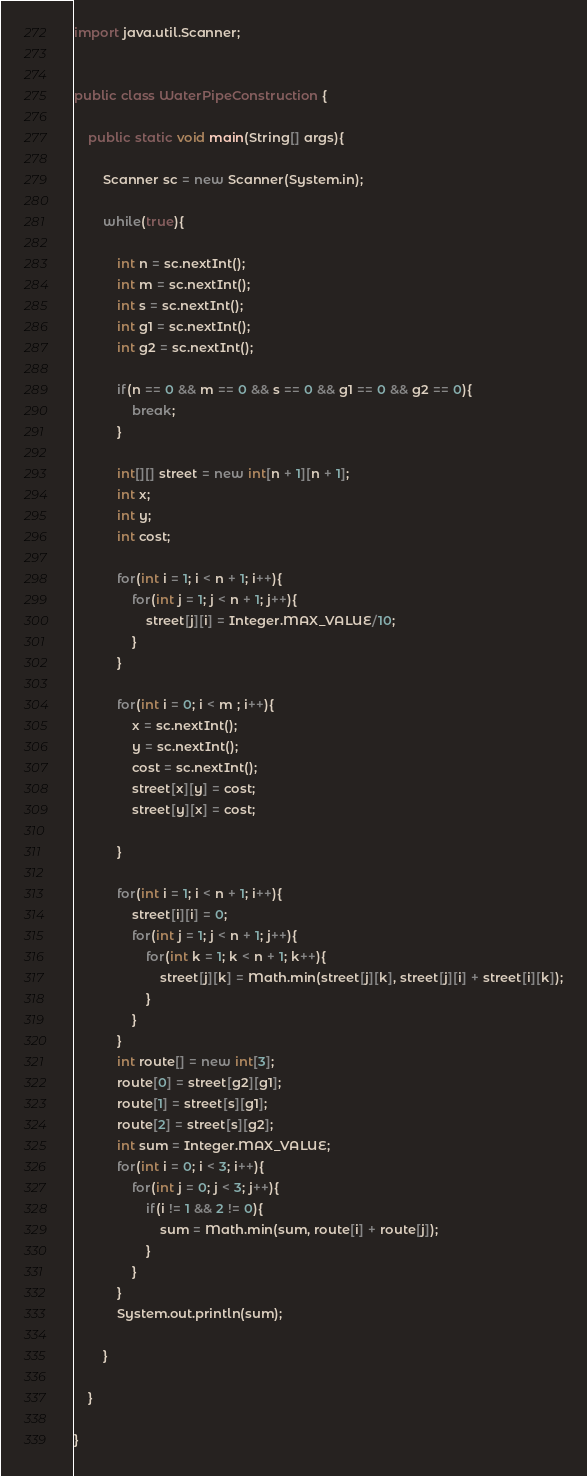Convert code to text. <code><loc_0><loc_0><loc_500><loc_500><_Java_>import java.util.Scanner;


public class WaterPipeConstruction {
	
	public static void main(String[] args){
		
		Scanner sc = new Scanner(System.in);
		
		while(true){
			
			int n = sc.nextInt();
			int m = sc.nextInt();
			int s = sc.nextInt();
			int g1 = sc.nextInt();
			int g2 = sc.nextInt();
			
			if(n == 0 && m == 0 && s == 0 && g1 == 0 && g2 == 0){
				break;
			}
			
			int[][] street = new int[n + 1][n + 1];
			int x;
			int y;
			int cost;
			
			for(int i = 1; i < n + 1; i++){
				for(int j = 1; j < n + 1; j++){
					street[j][i] = Integer.MAX_VALUE/10;
				}
			}
			
			for(int i = 0; i < m ; i++){
				x = sc.nextInt();
				y = sc.nextInt();
				cost = sc.nextInt();
				street[x][y] = cost;
				street[y][x] = cost;
				
			}
			
			for(int i = 1; i < n + 1; i++){
				street[i][i] = 0;
				for(int j = 1; j < n + 1; j++){
					for(int k = 1; k < n + 1; k++){
						street[j][k] = Math.min(street[j][k], street[j][i] + street[i][k]);
					}
				}
			}
			int route[] = new int[3];
			route[0] = street[g2][g1];
			route[1] = street[s][g1];
			route[2] = street[s][g2];
			int sum = Integer.MAX_VALUE;
			for(int i = 0; i < 3; i++){
				for(int j = 0; j < 3; j++){
					if(i != 1 && 2 != 0){
						sum = Math.min(sum, route[i] + route[j]);
					}
				}
			}
			System.out.println(sum);
			
		}
		
	}

}</code> 